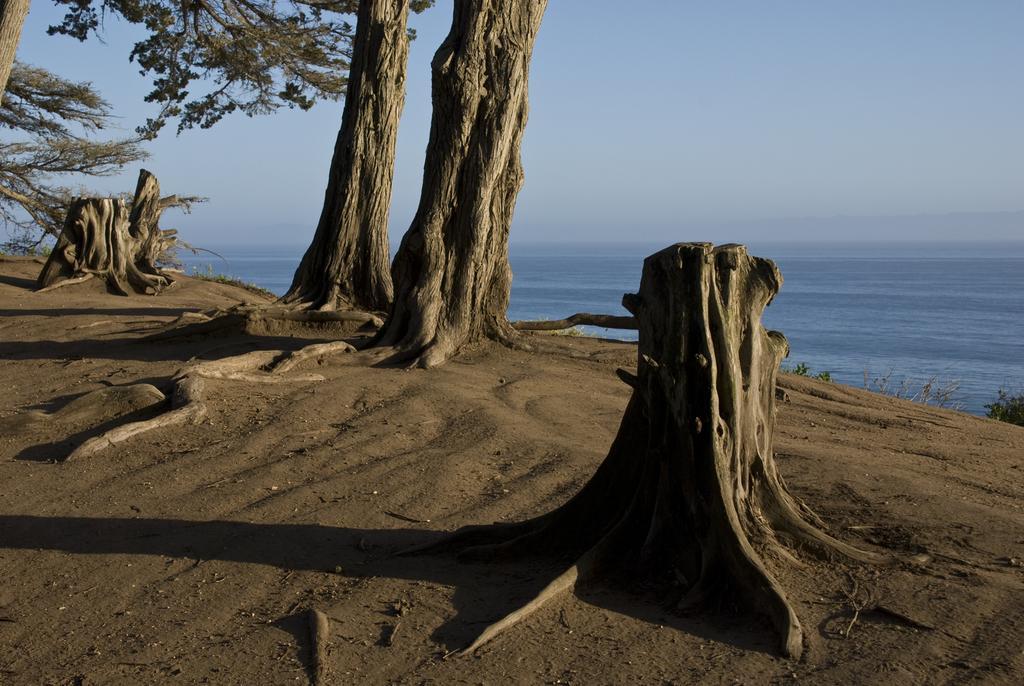Describe this image in one or two sentences. In this image we can see a group of trees and tree stumps and in the background, we can see the water and the sky. 